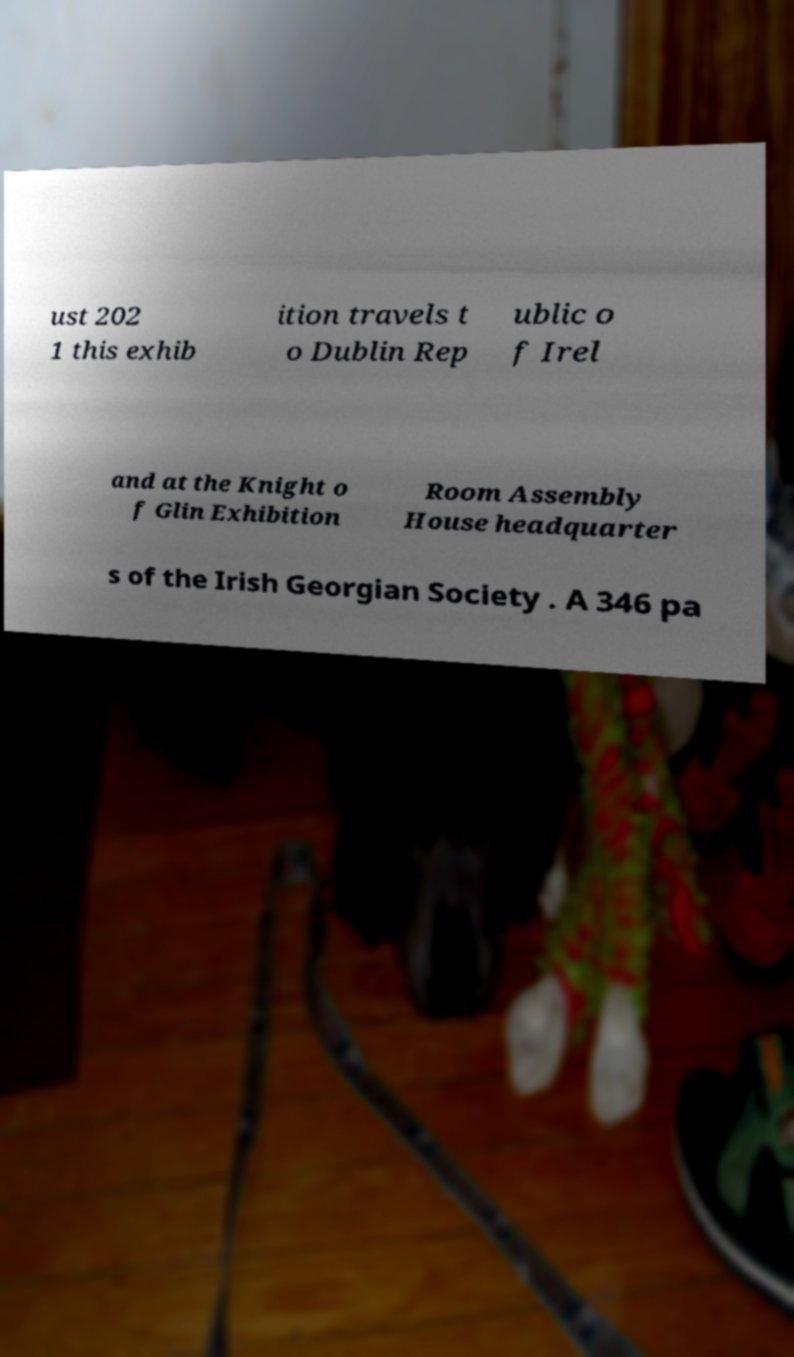Could you assist in decoding the text presented in this image and type it out clearly? ust 202 1 this exhib ition travels t o Dublin Rep ublic o f Irel and at the Knight o f Glin Exhibition Room Assembly House headquarter s of the Irish Georgian Society . A 346 pa 